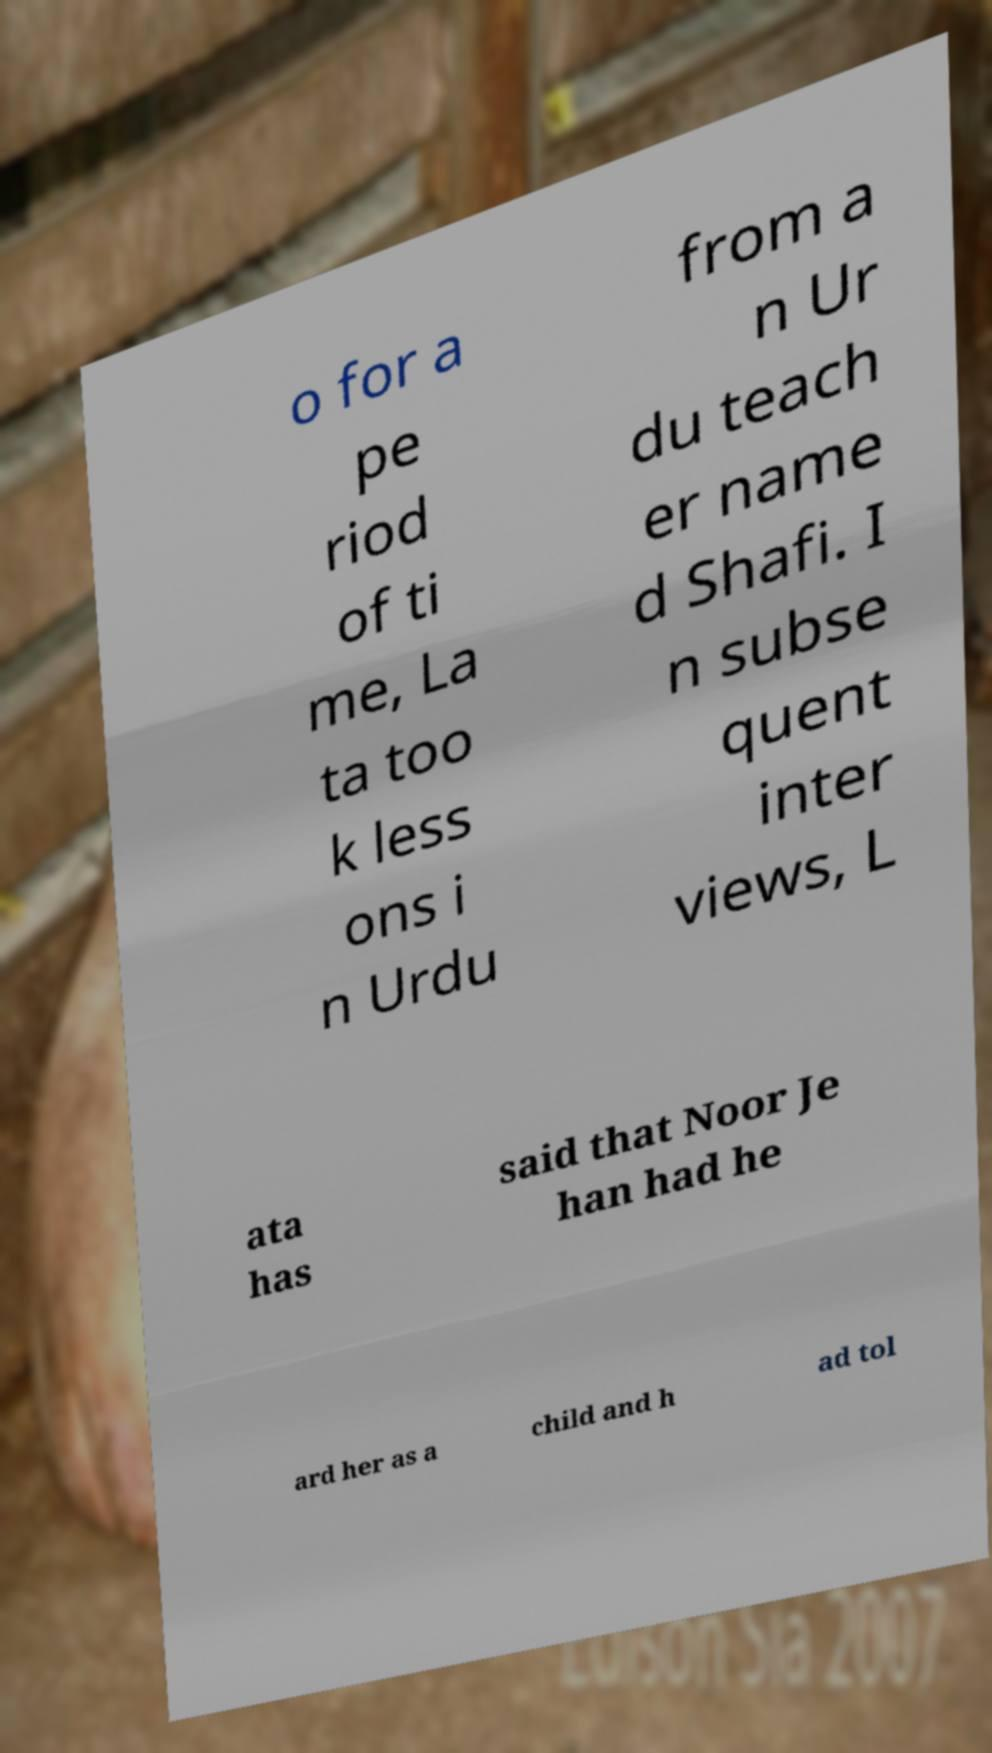Could you extract and type out the text from this image? o for a pe riod of ti me, La ta too k less ons i n Urdu from a n Ur du teach er name d Shafi. I n subse quent inter views, L ata has said that Noor Je han had he ard her as a child and h ad tol 